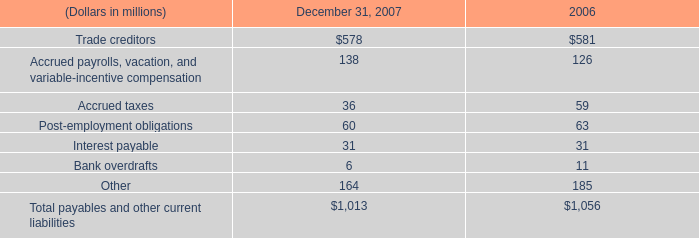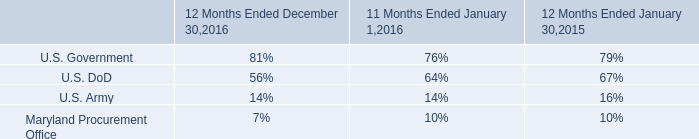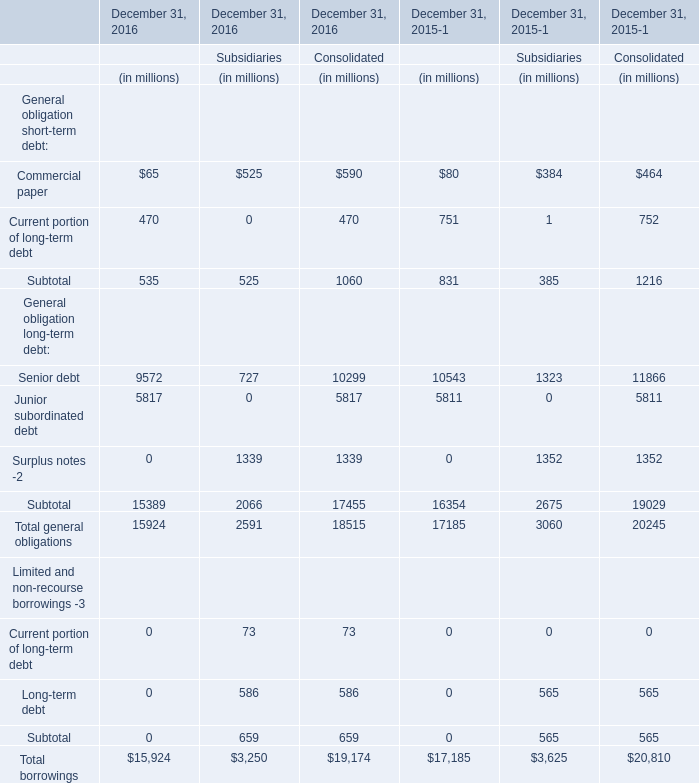what was the ratio of the investment prior to sale to the pre-tax gain on the sale 
Computations: (246 / 171)
Answer: 1.4386. 